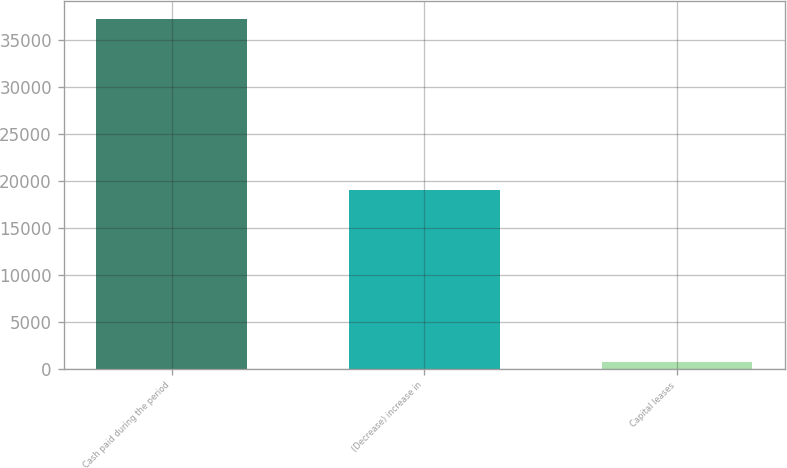Convert chart to OTSL. <chart><loc_0><loc_0><loc_500><loc_500><bar_chart><fcel>Cash paid during the period<fcel>(Decrease) increase in<fcel>Capital leases<nl><fcel>37292.6<fcel>19040.8<fcel>789<nl></chart> 